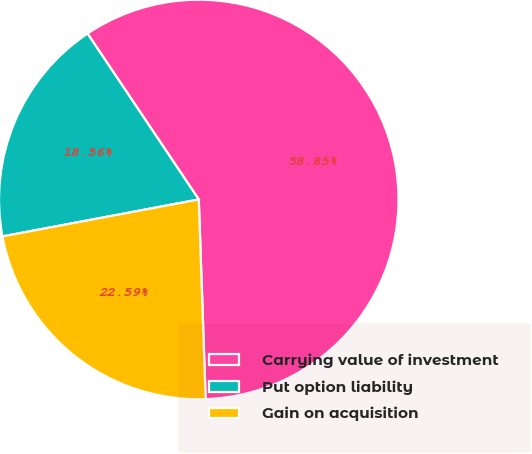<chart> <loc_0><loc_0><loc_500><loc_500><pie_chart><fcel>Carrying value of investment<fcel>Put option liability<fcel>Gain on acquisition<nl><fcel>58.86%<fcel>18.56%<fcel>22.59%<nl></chart> 